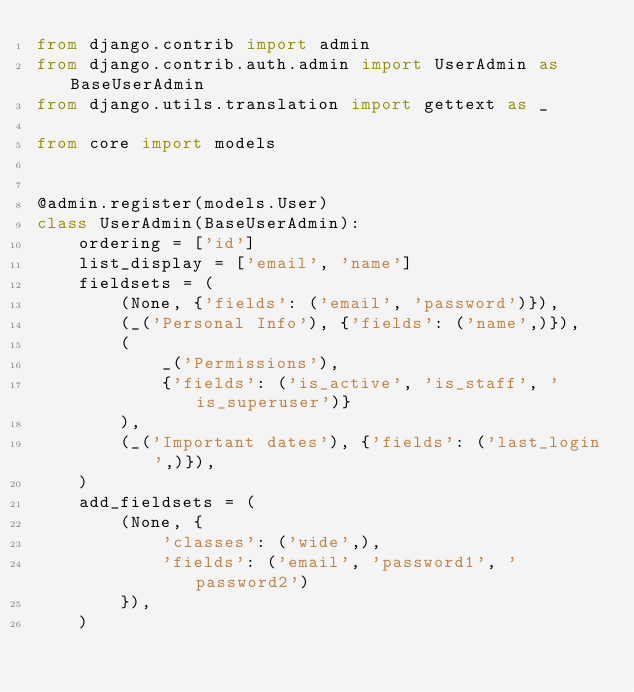Convert code to text. <code><loc_0><loc_0><loc_500><loc_500><_Python_>from django.contrib import admin
from django.contrib.auth.admin import UserAdmin as BaseUserAdmin
from django.utils.translation import gettext as _

from core import models


@admin.register(models.User)
class UserAdmin(BaseUserAdmin):
    ordering = ['id']
    list_display = ['email', 'name']
    fieldsets = (
        (None, {'fields': ('email', 'password')}),
        (_('Personal Info'), {'fields': ('name',)}),
        (
            _('Permissions'),
            {'fields': ('is_active', 'is_staff', 'is_superuser')}
        ),
        (_('Important dates'), {'fields': ('last_login',)}),
    )
    add_fieldsets = (
        (None, {
            'classes': ('wide',),
            'fields': ('email', 'password1', 'password2')
        }),
    )
</code> 